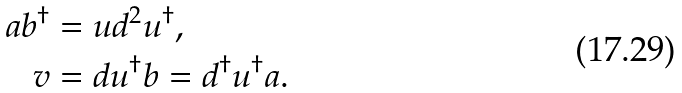<formula> <loc_0><loc_0><loc_500><loc_500>a b ^ { \dagger } & = u d ^ { 2 } u ^ { \dagger } , \\ v & = d u ^ { \dagger } b = d ^ { \dagger } u ^ { \dagger } a .</formula> 